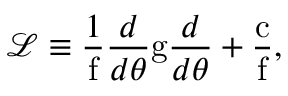Convert formula to latex. <formula><loc_0><loc_0><loc_500><loc_500>\mathcal { L } \equiv \frac { 1 } { f } \frac { d } { d \theta } g \frac { d } { d \theta } + \frac { c } { f } ,</formula> 